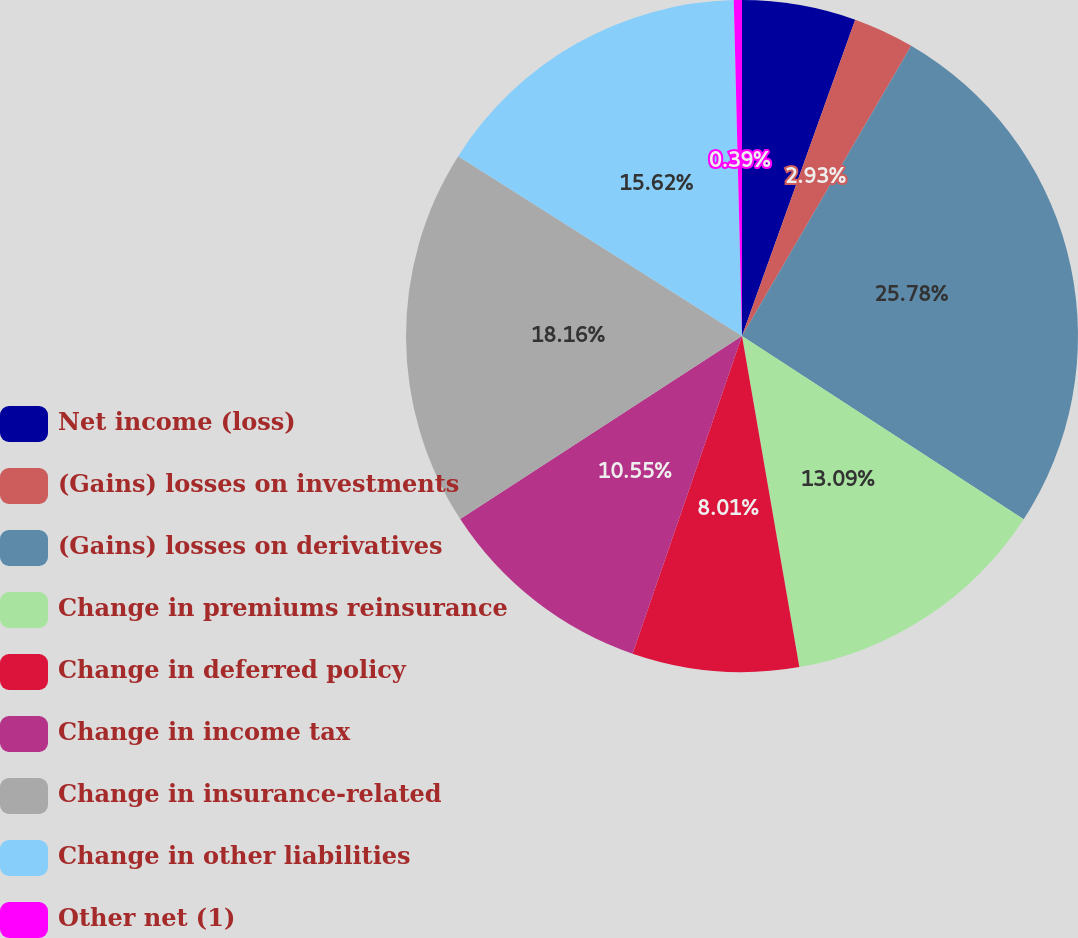Convert chart to OTSL. <chart><loc_0><loc_0><loc_500><loc_500><pie_chart><fcel>Net income (loss)<fcel>(Gains) losses on investments<fcel>(Gains) losses on derivatives<fcel>Change in premiums reinsurance<fcel>Change in deferred policy<fcel>Change in income tax<fcel>Change in insurance-related<fcel>Change in other liabilities<fcel>Other net (1)<nl><fcel>5.47%<fcel>2.93%<fcel>25.78%<fcel>13.09%<fcel>8.01%<fcel>10.55%<fcel>18.16%<fcel>15.62%<fcel>0.39%<nl></chart> 